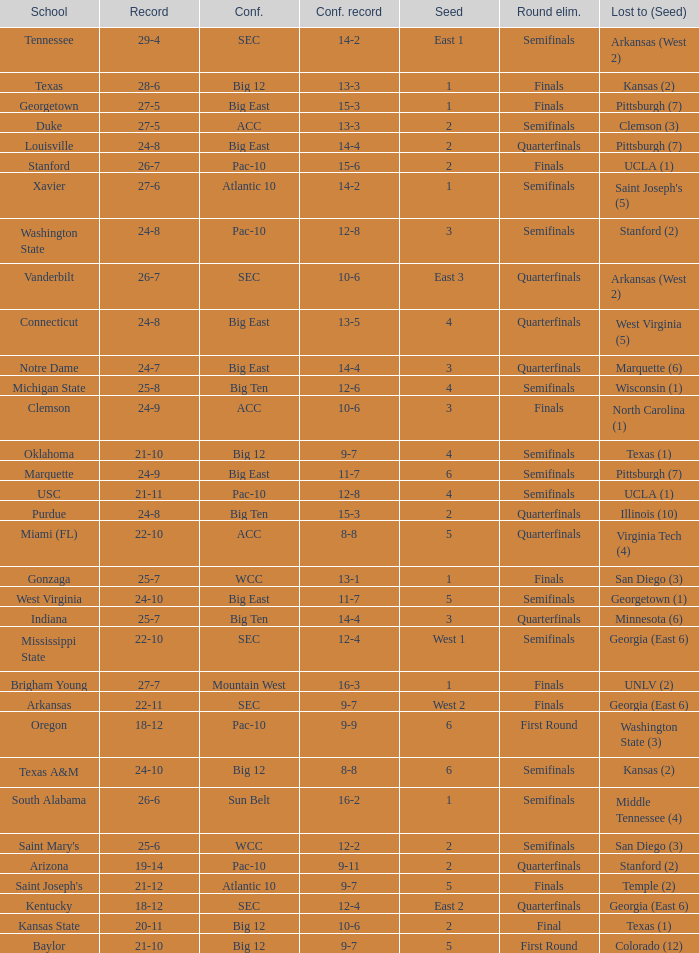Name the round eliminated where conference record is 12-6 Semifinals. 